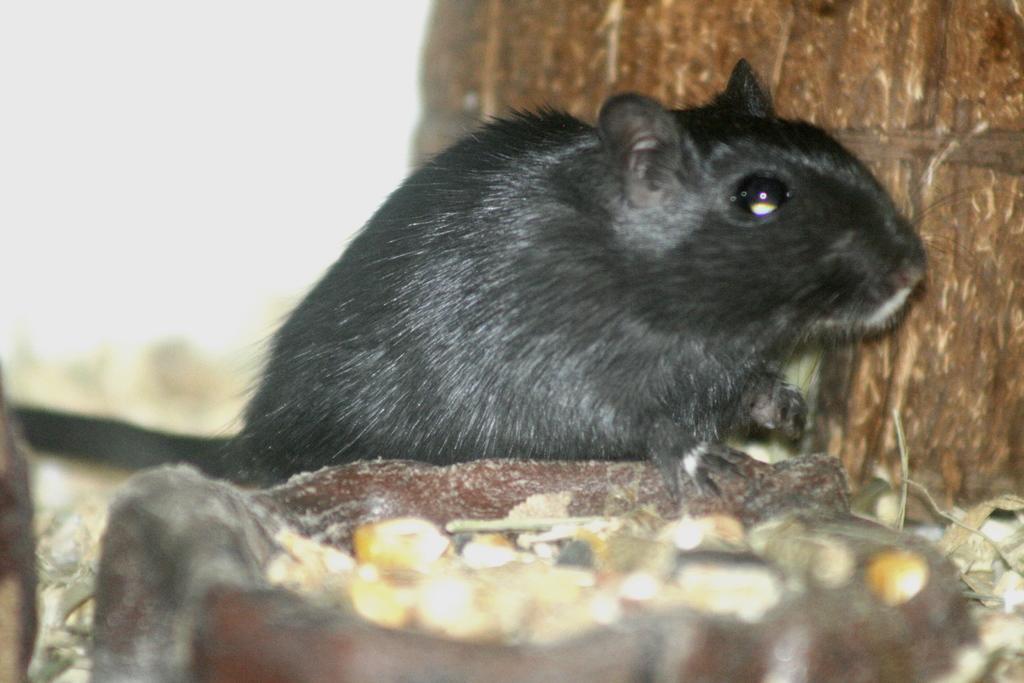In one or two sentences, can you explain what this image depicts? This image is taken outdoors. On the right side of the image there is a tree. In the middle of the image there is a rat. At the bottom of the image there is a bowl with a few grains in it. 